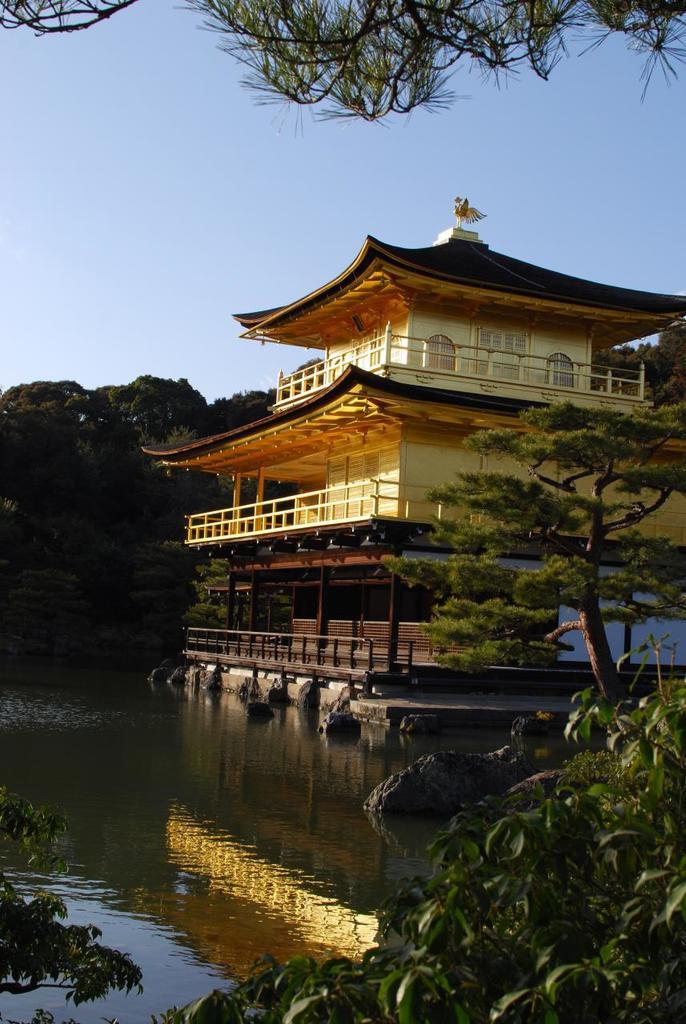What is the main subject in the center of the image? There is a plant in the center of the image. What can be seen in the background of the image? Water, a building, and trees are visible in the background of the image. Where is the nest located in the image? There is no nest present in the image. What type of fruit can be seen hanging from the plant in the image? There is no fruit visible on the plant in the image. 